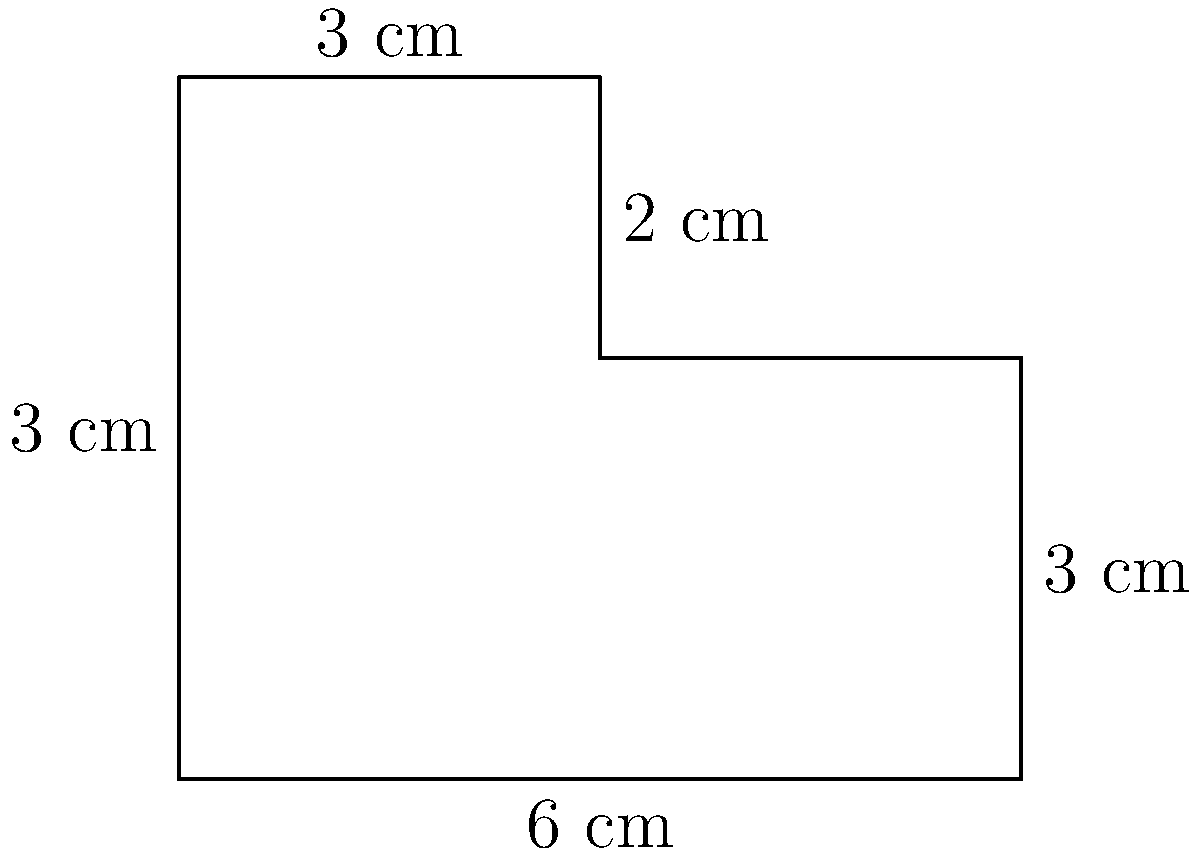A luxury glass manufacturer wants to create an irregularly shaped tabletop for a high-end client. The shape of the tabletop is shown in the diagram above, with measurements in centimeters. Calculate the perimeter and area of this glass tabletop. How much would the material cost for this tabletop if high-quality glass costs $250 per square meter? Let's approach this step-by-step:

1. Calculate the perimeter:
   Perimeter = 6 + 3 + 2 + 3 + 3 + 5 = 22 cm

2. Calculate the area:
   We can divide the shape into a rectangle and a square.
   Rectangle area: 6 * 3 = 18 cm²
   Square area: 3 * 2 = 6 cm²
   Total area: 18 + 6 = 24 cm²

3. Convert the area to square meters:
   24 cm² = 0.0024 m²

4. Calculate the cost:
   Cost per m² = $250
   Total cost = 0.0024 m² * $250/m² = $0.60

Therefore, the perimeter is 22 cm, the area is 24 cm² (0.0024 m²), and the material cost would be $0.60.
Answer: Perimeter: 22 cm, Area: 24 cm², Cost: $0.60 